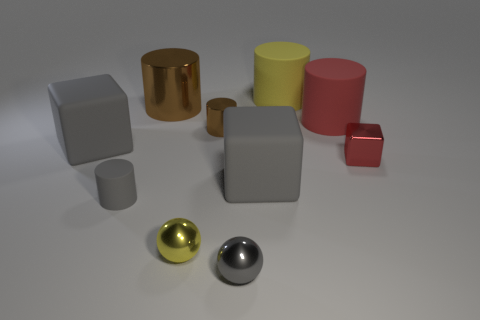There is a metallic cylinder that is on the left side of the yellow sphere; what is its size?
Keep it short and to the point. Large. How many small red things are made of the same material as the small yellow ball?
Your answer should be very brief. 1. What is the shape of the large object that is the same color as the tiny metal block?
Make the answer very short. Cylinder. Is the shape of the large object to the left of the tiny gray matte thing the same as  the small red thing?
Ensure brevity in your answer.  Yes. What is the color of the cube that is the same material as the large brown thing?
Your answer should be compact. Red. There is a cube that is on the left side of the gray ball in front of the yellow rubber object; is there a large gray cube behind it?
Provide a succinct answer. No. The tiny red shiny object has what shape?
Make the answer very short. Cube. Is the number of matte cubes that are right of the small gray metal thing less than the number of large yellow metal cubes?
Make the answer very short. No. Are there any tiny yellow metal things that have the same shape as the large red object?
Ensure brevity in your answer.  No. What is the shape of the matte object that is the same size as the yellow shiny ball?
Offer a very short reply. Cylinder. 